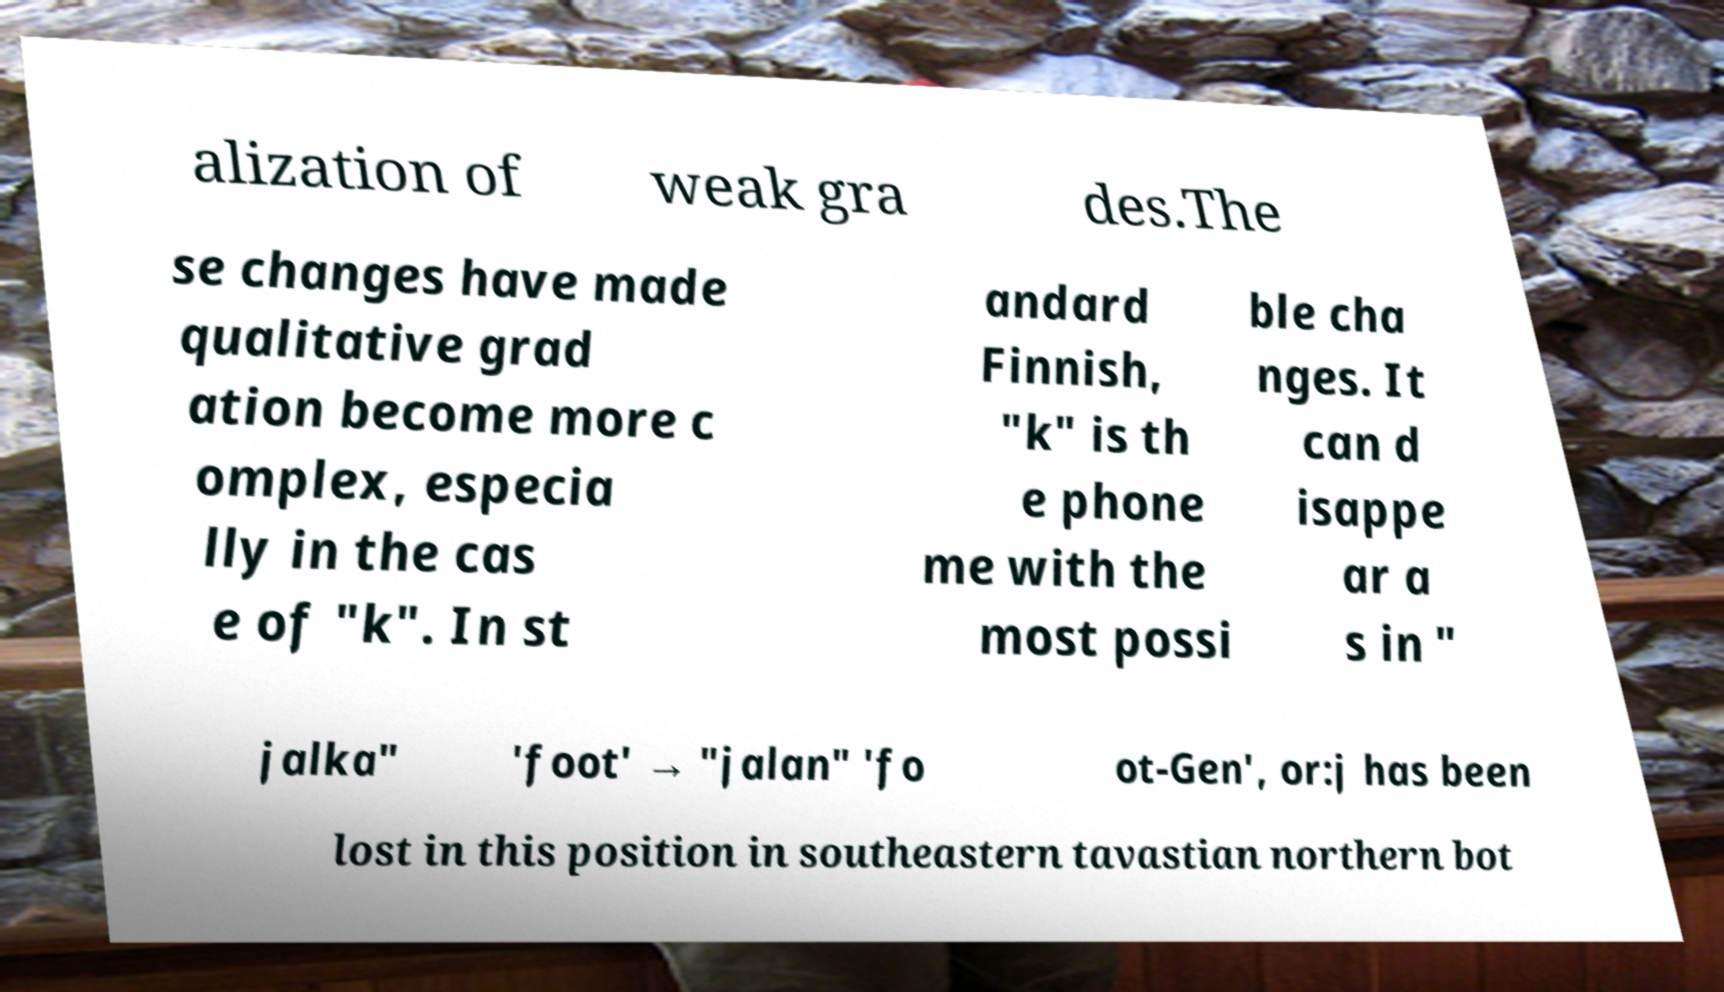I need the written content from this picture converted into text. Can you do that? alization of weak gra des.The se changes have made qualitative grad ation become more c omplex, especia lly in the cas e of "k". In st andard Finnish, "k" is th e phone me with the most possi ble cha nges. It can d isappe ar a s in " jalka" 'foot' → "jalan" 'fo ot-Gen', or:j has been lost in this position in southeastern tavastian northern bot 